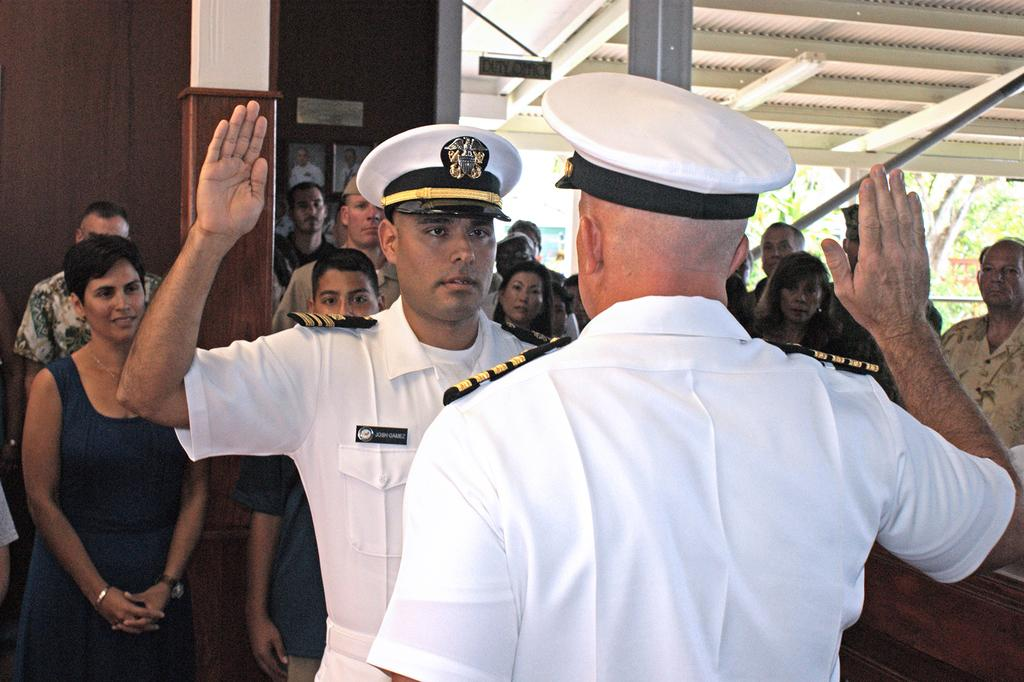What are the people in the image doing? Some people are standing, and some are raising their hands. Can you describe any accessories that the people are wearing? Some people are wearing caps on their heads. What can be seen on the wall in the image? There are photo frames on the wall. What type of natural elements are visible in the image? Trees are visible in the image. How many baby trucks can be seen driving through the sense in the image? There are no baby trucks or senses present in the image. 